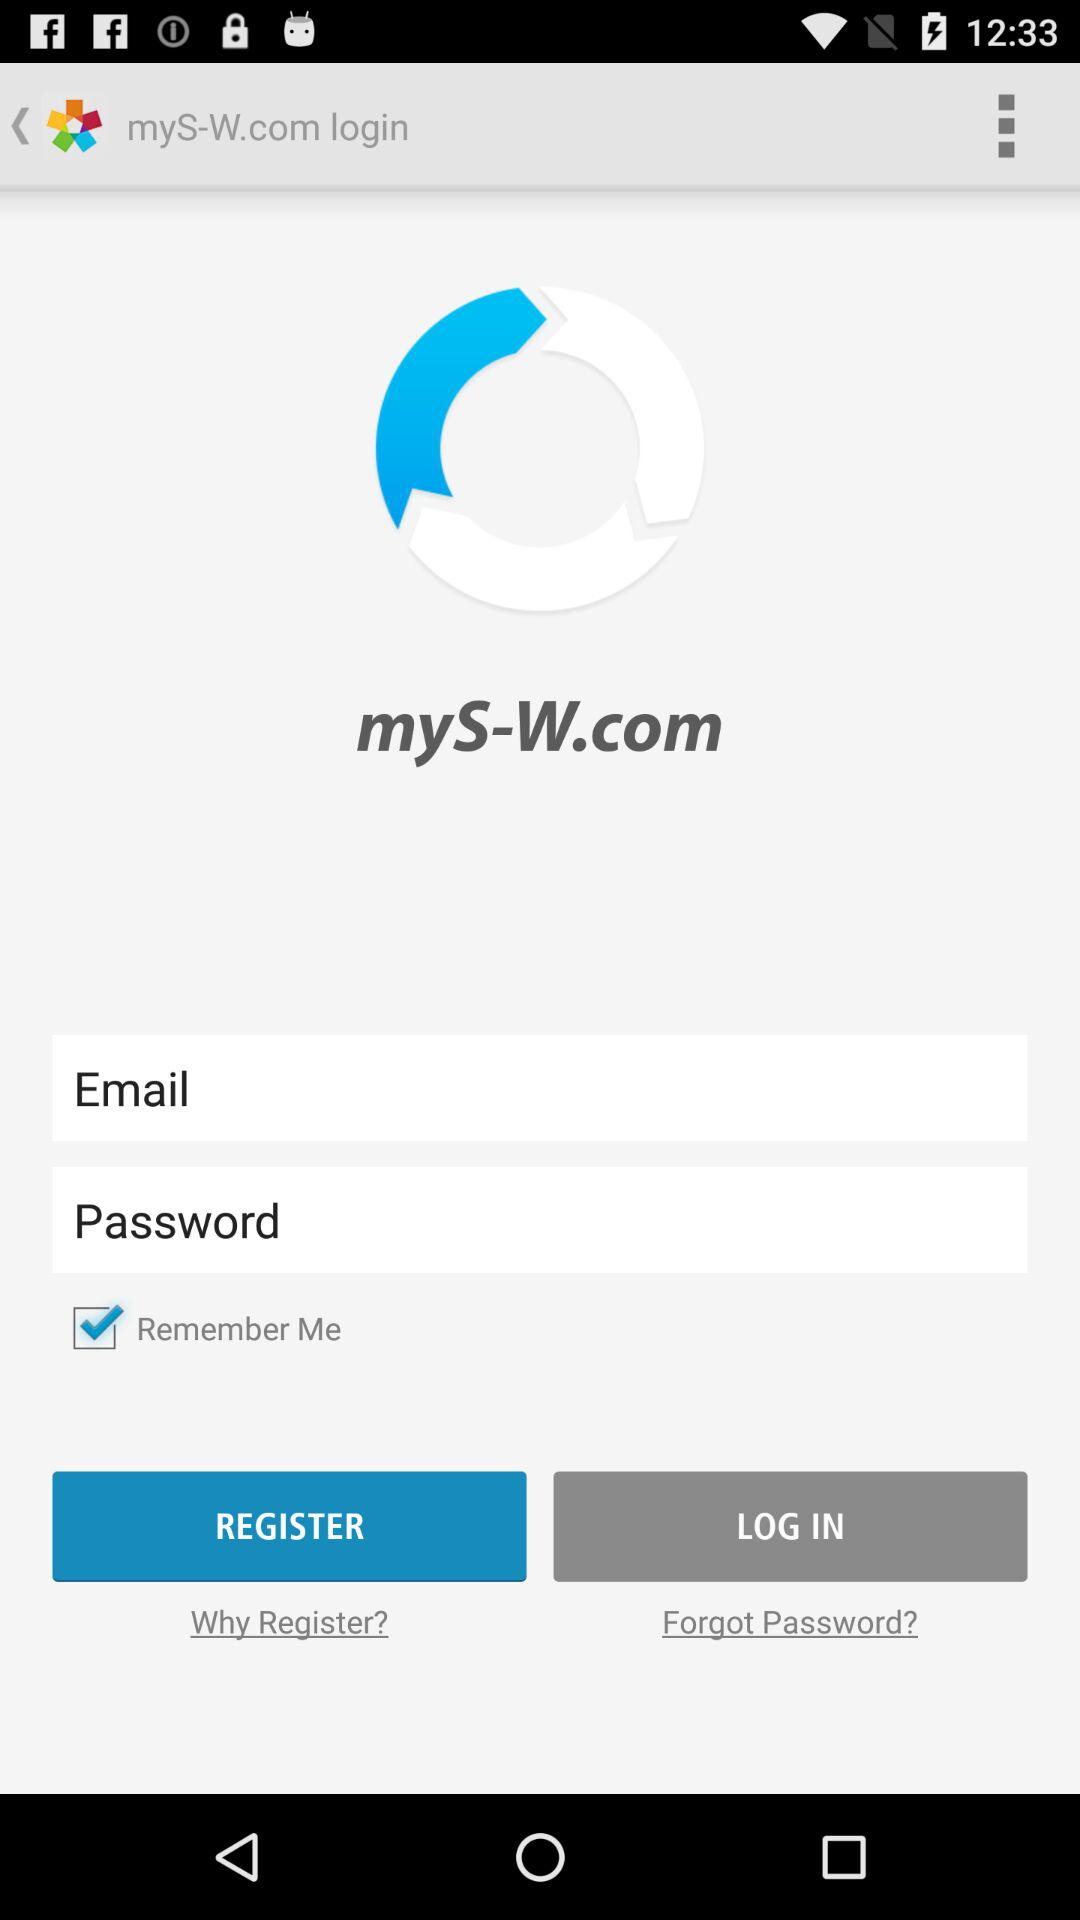Can we reset password?
When the provided information is insufficient, respond with <no answer>. <no answer> 